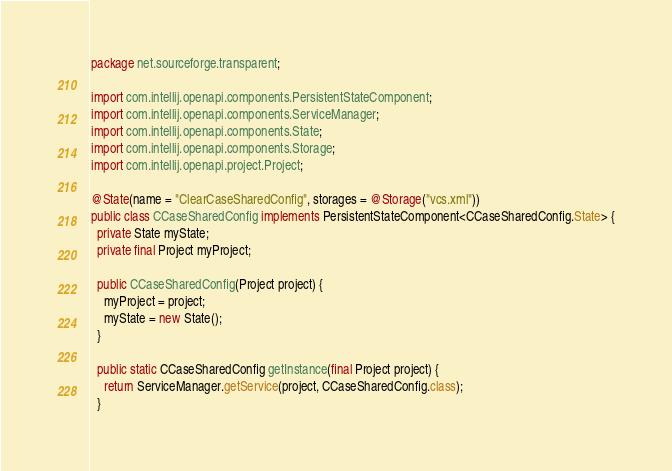<code> <loc_0><loc_0><loc_500><loc_500><_Java_>package net.sourceforge.transparent;

import com.intellij.openapi.components.PersistentStateComponent;
import com.intellij.openapi.components.ServiceManager;
import com.intellij.openapi.components.State;
import com.intellij.openapi.components.Storage;
import com.intellij.openapi.project.Project;

@State(name = "ClearCaseSharedConfig", storages = @Storage("vcs.xml"))
public class CCaseSharedConfig implements PersistentStateComponent<CCaseSharedConfig.State> {
  private State myState;
  private final Project myProject;

  public CCaseSharedConfig(Project project) {
    myProject = project;
    myState = new State();
  }

  public static CCaseSharedConfig getInstance(final Project project) {
    return ServiceManager.getService(project, CCaseSharedConfig.class);
  }
</code> 